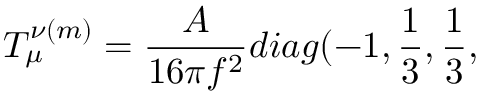Convert formula to latex. <formula><loc_0><loc_0><loc_500><loc_500>T _ { \mu } ^ { \nu ( m ) } = \frac { A } { 1 6 \pi f ^ { 2 } } d i a g ( - 1 , \frac { 1 } { 3 } , \frac { 1 } { 3 } ,</formula> 